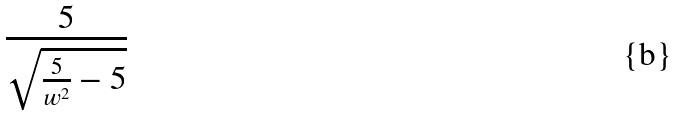<formula> <loc_0><loc_0><loc_500><loc_500>\frac { 5 } { \sqrt { \frac { 5 } { w ^ { 2 } } - 5 } }</formula> 